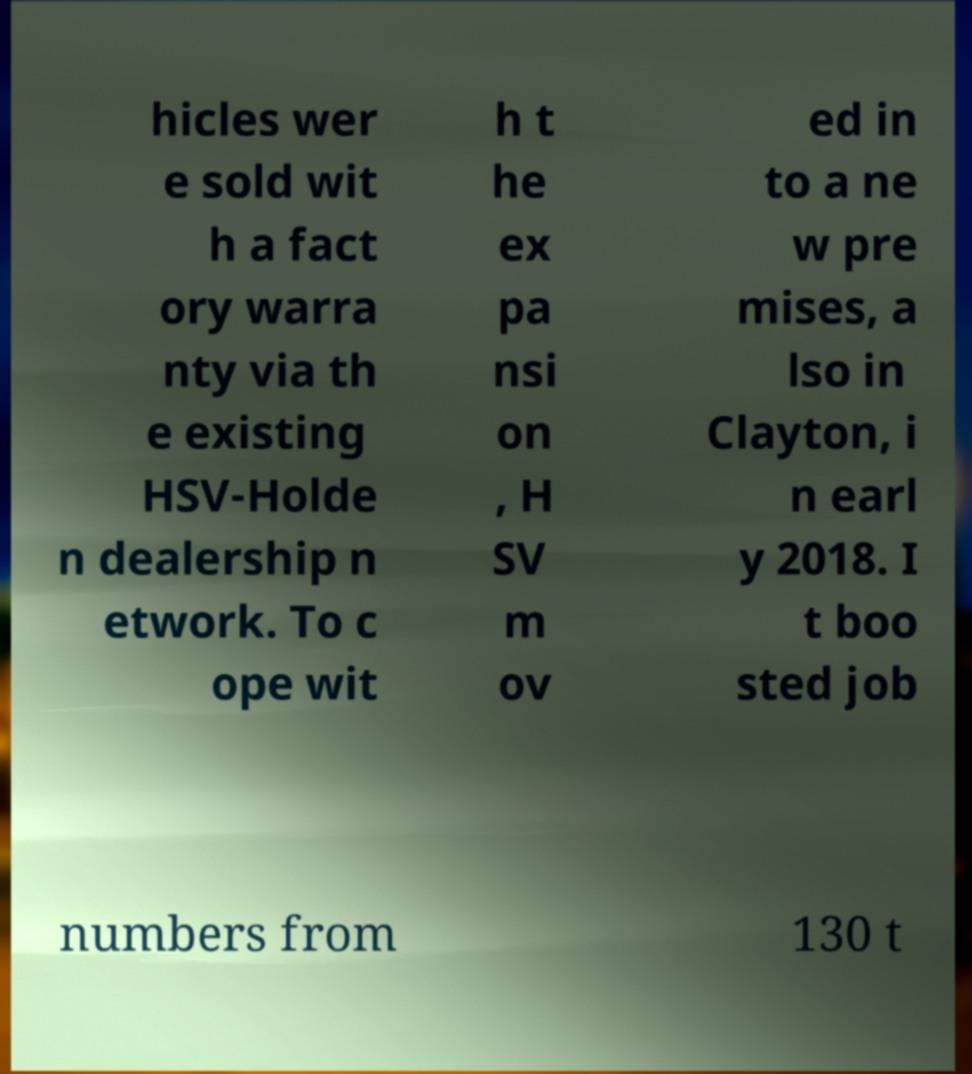What messages or text are displayed in this image? I need them in a readable, typed format. hicles wer e sold wit h a fact ory warra nty via th e existing HSV-Holde n dealership n etwork. To c ope wit h t he ex pa nsi on , H SV m ov ed in to a ne w pre mises, a lso in Clayton, i n earl y 2018. I t boo sted job numbers from 130 t 